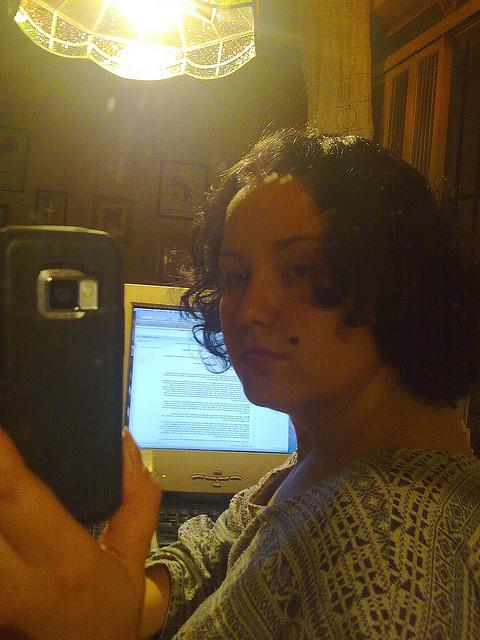What is on the woman's lip who is holding the camera in front of the computer? Please explain your reasoning. lipstick. The woman is wearing some lipstick on her lips. 